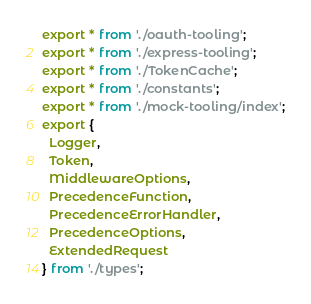<code> <loc_0><loc_0><loc_500><loc_500><_TypeScript_>export * from './oauth-tooling';
export * from './express-tooling';
export * from './TokenCache';
export * from './constants';
export * from './mock-tooling/index';
export {
  Logger,
  Token,
  MiddlewareOptions,
  PrecedenceFunction,
  PrecedenceErrorHandler,
  PrecedenceOptions,
  ExtendedRequest
} from './types';
</code> 